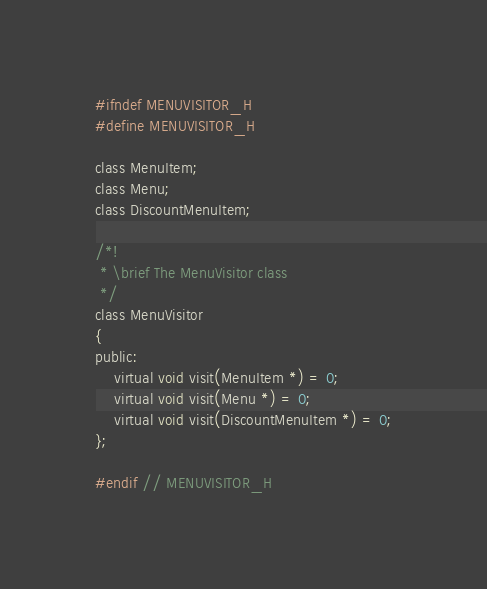Convert code to text. <code><loc_0><loc_0><loc_500><loc_500><_C_>#ifndef MENUVISITOR_H
#define MENUVISITOR_H

class MenuItem;
class Menu;
class DiscountMenuItem;

/*!
 * \brief The MenuVisitor class
 */
class MenuVisitor
{
public:
    virtual void visit(MenuItem *) = 0;
    virtual void visit(Menu *) = 0;
    virtual void visit(DiscountMenuItem *) = 0;
};

#endif // MENUVISITOR_H
</code> 